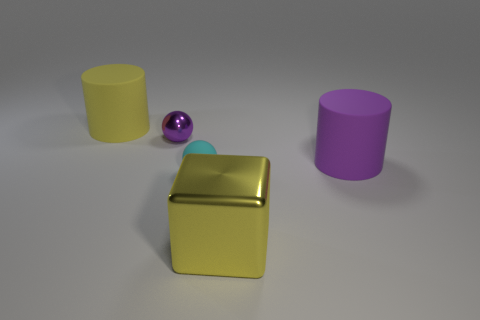Are there any shiny things of the same color as the cube?
Your answer should be very brief. No. There is a matte thing that is the same size as the purple cylinder; what is its color?
Keep it short and to the point. Yellow. Do the big purple rubber object and the yellow metal thing have the same shape?
Keep it short and to the point. No. There is a large cylinder on the right side of the big yellow cylinder; what is its material?
Offer a very short reply. Rubber. What color is the rubber sphere?
Ensure brevity in your answer.  Cyan. There is a metallic thing behind the big metal object; is it the same size as the object that is in front of the small cyan matte object?
Your response must be concise. No. There is a object that is both behind the small cyan rubber thing and to the right of the small cyan thing; what size is it?
Provide a succinct answer. Large. What is the color of the small shiny thing that is the same shape as the tiny matte thing?
Offer a very short reply. Purple. Are there more rubber spheres that are behind the tiny cyan rubber sphere than rubber cylinders right of the small metallic ball?
Your response must be concise. No. How many other objects are there of the same shape as the cyan rubber object?
Keep it short and to the point. 1. 